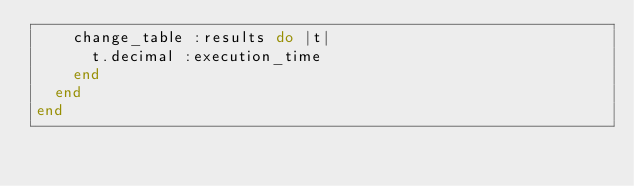<code> <loc_0><loc_0><loc_500><loc_500><_Ruby_>    change_table :results do |t|
      t.decimal :execution_time
    end
  end
end
</code> 